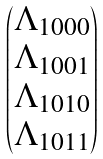<formula> <loc_0><loc_0><loc_500><loc_500>\begin{pmatrix} \Lambda _ { 1 0 0 0 } \\ \Lambda _ { 1 0 0 1 } \\ \Lambda _ { 1 0 1 0 } \\ \Lambda _ { 1 0 1 1 } \end{pmatrix}</formula> 